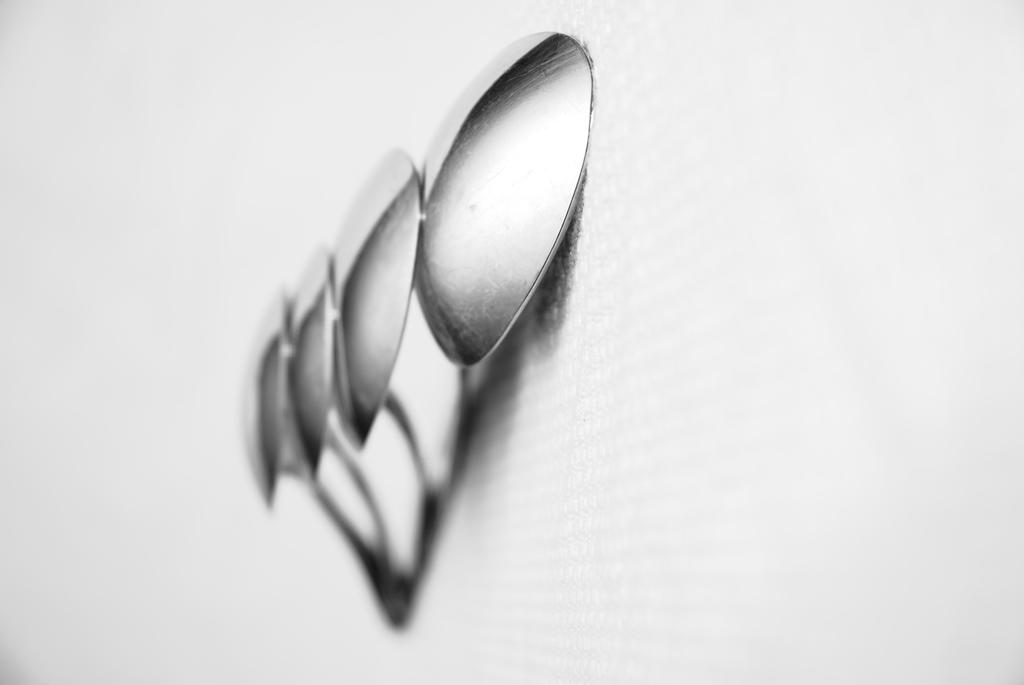How many spoons are visible in the image? There are four steel spoons in the image. What is the color of the background at the bottom of the image? The background of the image is white at the bottom. What type of bird can be seen perched on the handle of one of the spoons in the image? There are no birds present in the image, including robins. 